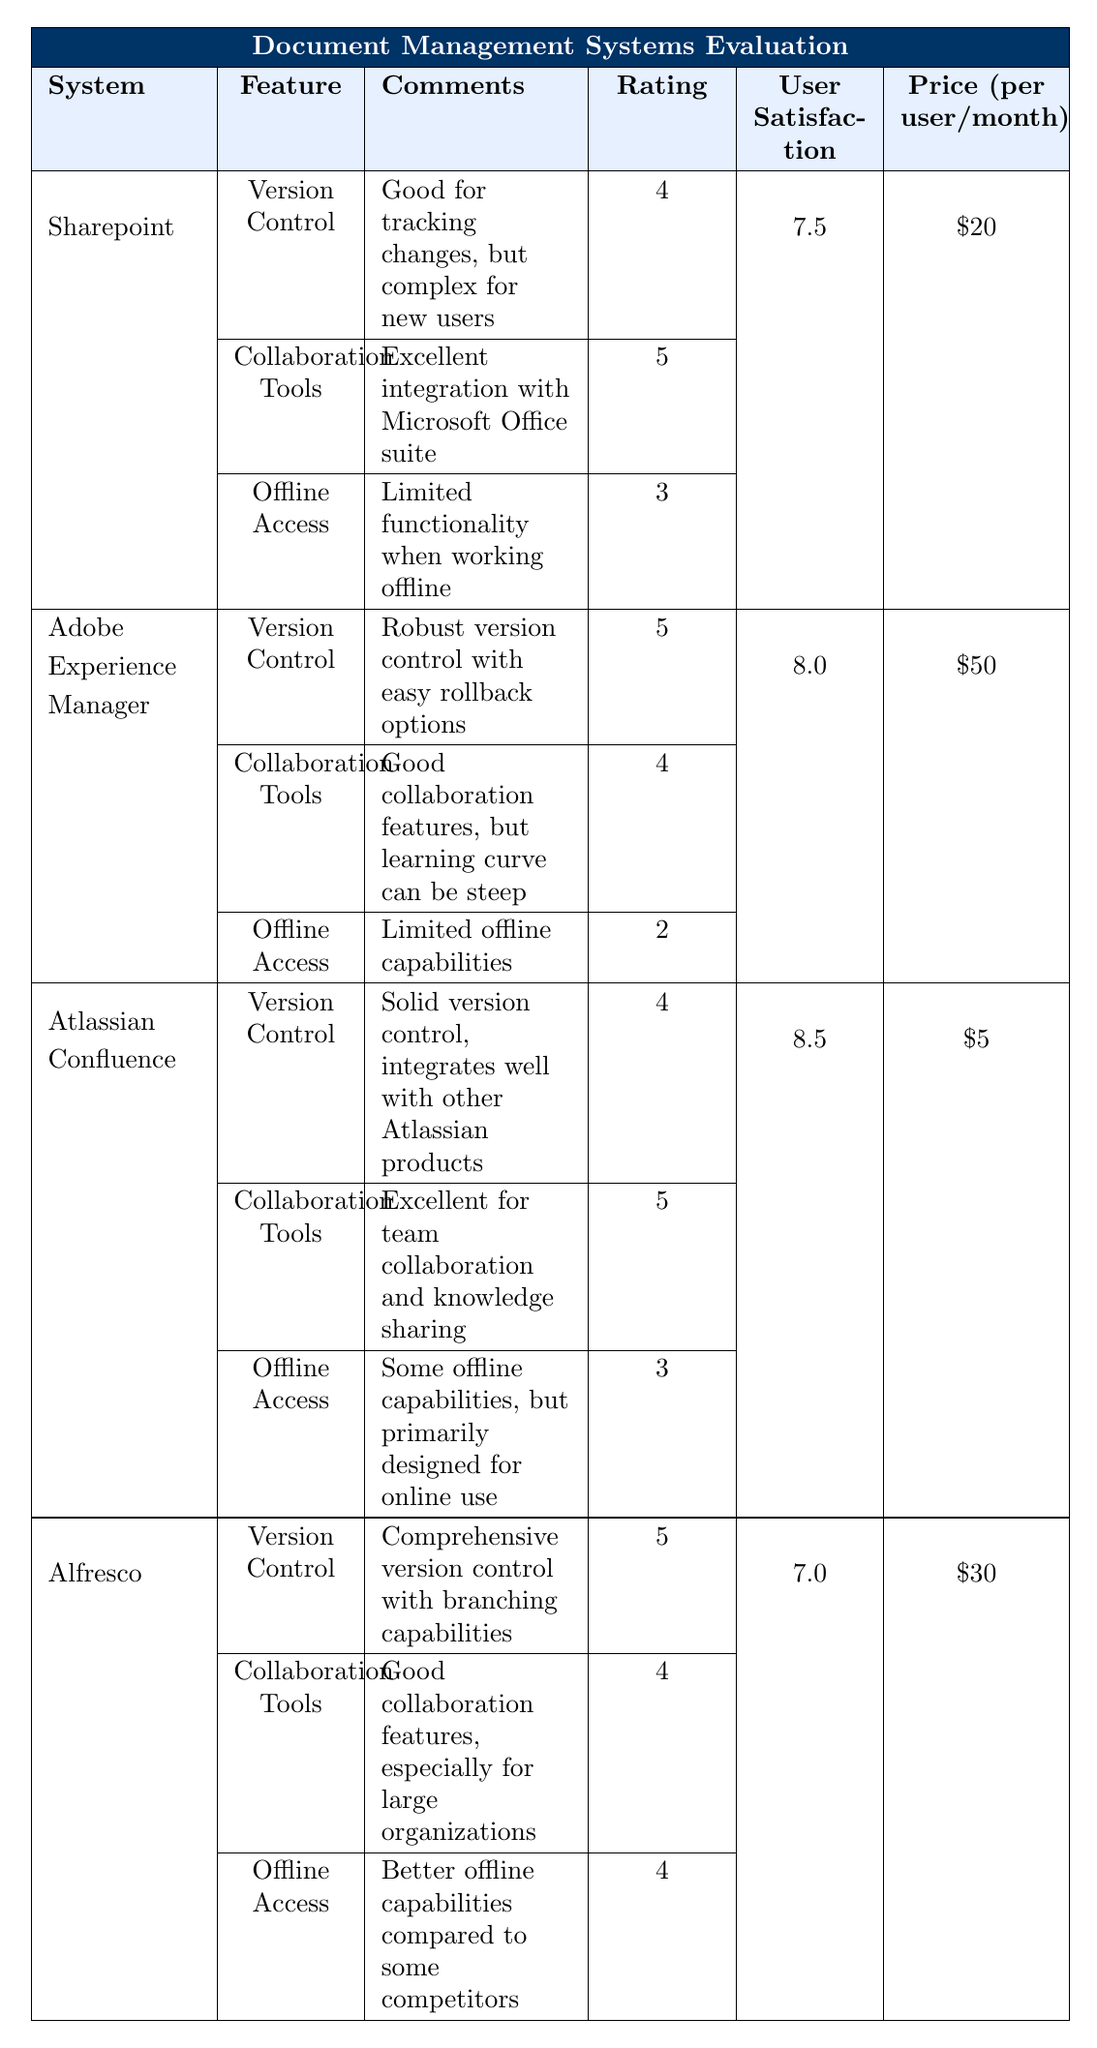What is the user satisfaction rating for Sharepoint? The table indicates that the user satisfaction rating for Sharepoint is listed under the "User Satisfaction" column and is 7.5.
Answer: 7.5 Which document management system has the highest rated collaboration tools? According to the ratings under the "Collaboration Tools" feature, Sharepoint has a rating of 5, which is the highest among all systems presented in the table.
Answer: Sharepoint What is the overall average user satisfaction rating of all systems? The user satisfaction ratings are 7.5, 8.0, 8.5, and 7.0 for Sharepoint, Adobe Experience Manager, Atlassian Confluence, and Alfresco respectively. Adding these ratings (7.5 + 8.0 + 8.5 + 7.0 = 31) and dividing by the number of systems (4) gives an average of 31/4 = 7.75.
Answer: 7.75 How many systems have offline access rated 4 or higher? In the table, only Alfresco has an offline access rating of 4, while the other systems (Sharepoint, Adobe Experience Manager, and Atlassian Confluence) have ratings of 3, 2, and 3, respectively. Therefore, only 1 system meets that criterion.
Answer: 1 Is the price for Atlassian Confluence lower than for Alfresco? Comparing the prices in the table, Atlassian Confluence is $5 per user/month, while Alfresco is $30 per user/month. Since $5 is lower than $30, the statement is true.
Answer: Yes Which system offers the best offline access and how does it compare to the others? According to the ratings, Alfresco has an offline access rating of 4, which is the highest compared to the other systems: Sharepoint (3), Adobe Experience Manager (2), and Atlassian Confluence (3). This highlights that Alfresco is the best for offline access.
Answer: Alfresco What is the price difference between Adobe Experience Manager and Sharepoint? The price for Adobe Experience Manager is $50 per user/month, while Sharepoint costs $20 per user/month. The difference can be calculated as $50 - $20 = $30.
Answer: $30 Which document management system has the best version control feature? Evaluating the ratings in the "Version Control" feature, both Adobe Experience Manager and Alfresco have a rating of 5, which is the highest among all the systems listed.
Answer: Adobe Experience Manager and Alfresco Does any system have a rating of 2 for offline access? The data shows that Adobe Experience Manager has an offline access rating of 2, confirming that at least one system meets this criterion.
Answer: Yes What is the overall trend in user satisfaction ratings from Sharepoint to Alfresco? The user satisfaction ratings are 7.5 (Sharepoint), 8.0 (Adobe), 8.5 (Atlassian), and 7.0 (Alfresco). The trend shows that satisfaction increases from Sharepoint to Atlassian Confluence and then decreases with Alfresco.
Answer: Increases then decreases 